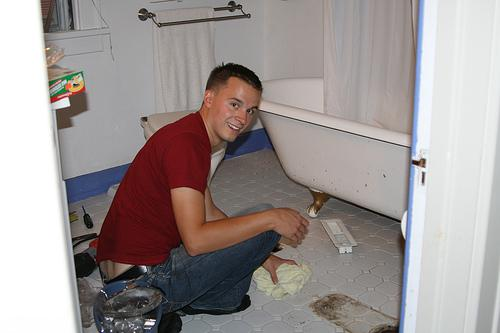Question: why is the man in the bathroom?
Choices:
A. He is washing his hands.
B. He is taking a shower.
C. He is using the toilet.
D. He is cleaning the bathroom.
Answer with the letter. Answer: D Question: what color shirt does the man have on?
Choices:
A. Aqua shirt.
B. White shirt.
C. Green shirt.
D. He has on a red shirt.
Answer with the letter. Answer: D Question: who is in the bathroom with the man?
Choices:
A. His wife is in the bathroom with him.
B. The man is in the bathroom with his son.
C. The man is in the bathroom with his daughter.
D. Nobody is in the bathroom with the man.
Answer with the letter. Answer: D Question: when was this picture taken?
Choices:
A. The picture was taken at night.
B. The picture seems to be taken in the morning.
C. The picture must have been taken in the afternoon.
D. This picture was probably taken in the day time.
Answer with the letter. Answer: D 